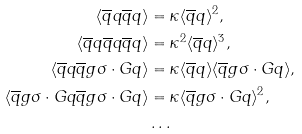<formula> <loc_0><loc_0><loc_500><loc_500>\langle \overline { q } q \overline { q } q \rangle & = \kappa \langle \overline { q } q \rangle ^ { 2 } , \\ \langle \overline { q } q \overline { q } q \overline { q } q \rangle & = \kappa ^ { 2 } \langle \overline { q } q \rangle ^ { 3 } , \\ \langle \overline { q } q \overline { q } g \sigma \cdot G q \rangle & = \kappa \langle \overline { q } q \rangle \langle \overline { q } g \sigma \cdot G q \rangle , \\ \langle \overline { q } g \sigma \cdot G q \overline { q } g \sigma \cdot G q \rangle & = \kappa \langle \overline { q } g \sigma \cdot G q \rangle ^ { 2 } , \\ & \dots</formula> 